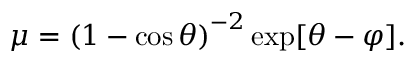<formula> <loc_0><loc_0><loc_500><loc_500>\mu = \left ( 1 - \cos \theta \right ) ^ { - 2 } \exp [ \theta - \varphi ] .</formula> 